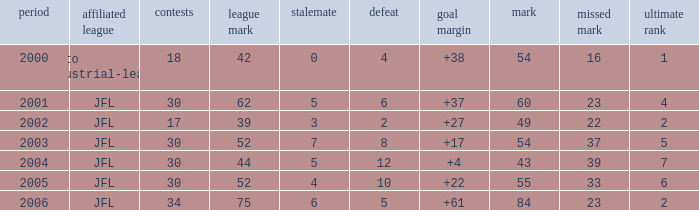I want the average lose for lost point more than 16 and goal difference less than 37 and point less than 43 None. 